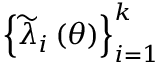<formula> <loc_0><loc_0><loc_500><loc_500>\left \{ { \widetilde { \lambda } } _ { i } \left ( \theta \right ) \right \} _ { i = 1 } ^ { k }</formula> 